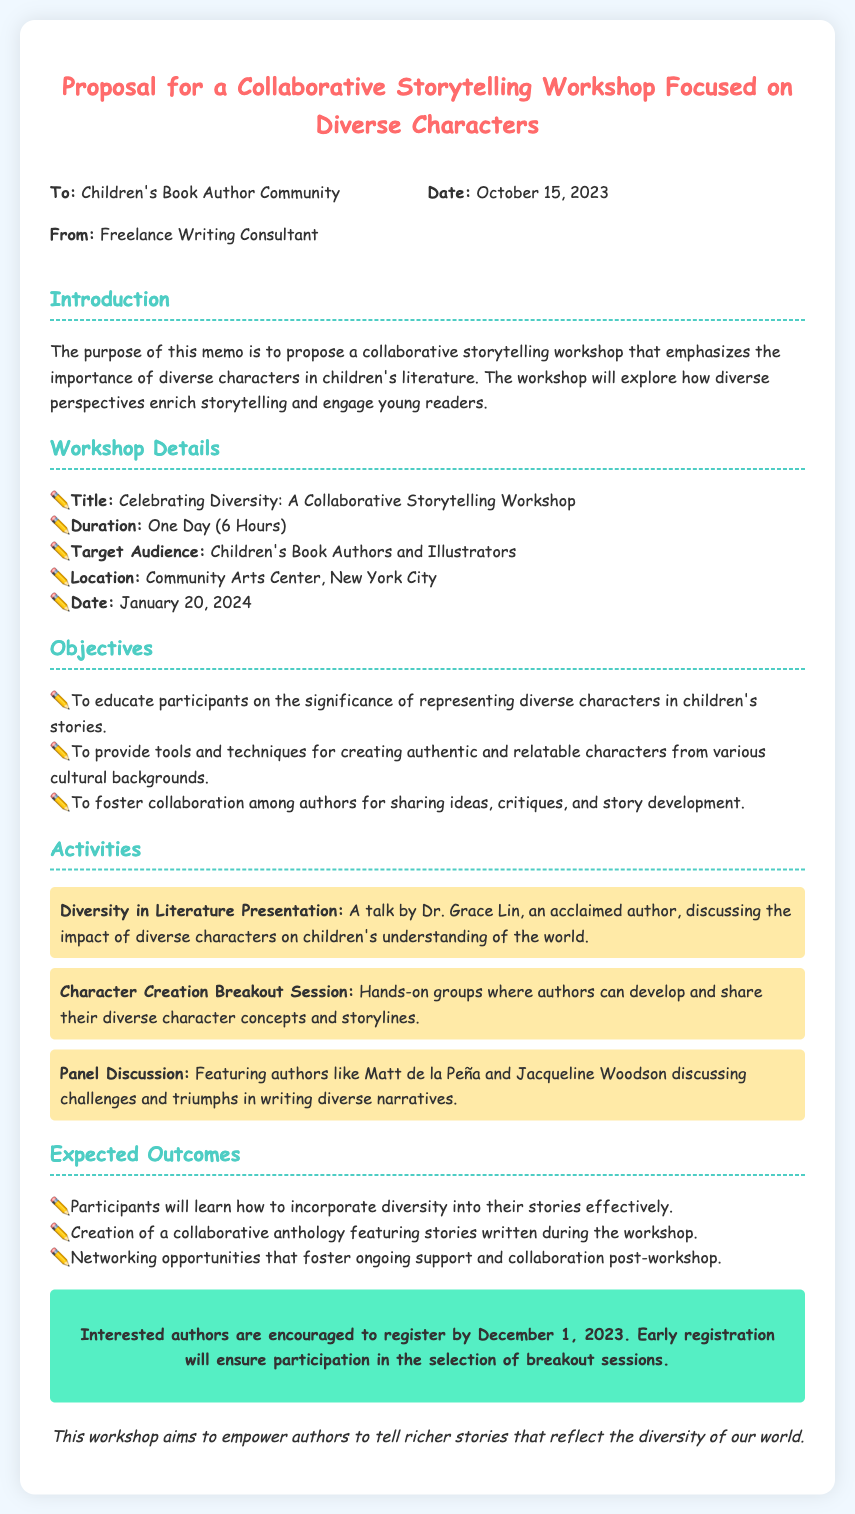what is the title of the workshop? The title is mentioned in the section about Workshop Details, specifying its purpose and theme.
Answer: Celebrating Diversity: A Collaborative Storytelling Workshop who is the target audience? The target audience is specified in the Workshop Details section, indicating who the workshop is designed for.
Answer: Children's Book Authors and Illustrators when is the workshop scheduled? The workshop date is clearly stated in the Workshop Details section.
Answer: January 20, 2024 who will present the Diversity in Literature talk? The presenter is listed in the Activities section, giving insight into who will be leading this discussion.
Answer: Dr. Grace Lin what is one of the expected outcomes of the workshop? Expected outcomes are listed in their own section, providing details about what participants will gain.
Answer: Participants will learn how to incorporate diversity into their stories effectively how long will the workshop last? The duration is provided in the Workshop Details section, outlining the length of the event.
Answer: One Day (6 Hours) what is the registration deadline? The registration deadline is mentioned in the call-to-action section, instructing interested participants.
Answer: December 1, 2023 who is the sender of this memo? The sender’s name is outlined in the header of the memo.
Answer: Freelance Writing Consultant 